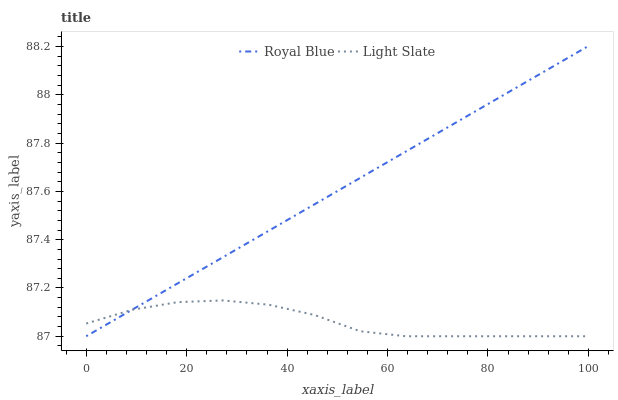Does Light Slate have the minimum area under the curve?
Answer yes or no. Yes. Does Royal Blue have the maximum area under the curve?
Answer yes or no. Yes. Does Royal Blue have the minimum area under the curve?
Answer yes or no. No. Is Royal Blue the smoothest?
Answer yes or no. Yes. Is Light Slate the roughest?
Answer yes or no. Yes. Is Royal Blue the roughest?
Answer yes or no. No. Does Light Slate have the lowest value?
Answer yes or no. Yes. Does Royal Blue have the highest value?
Answer yes or no. Yes. Does Royal Blue intersect Light Slate?
Answer yes or no. Yes. Is Royal Blue less than Light Slate?
Answer yes or no. No. Is Royal Blue greater than Light Slate?
Answer yes or no. No. 